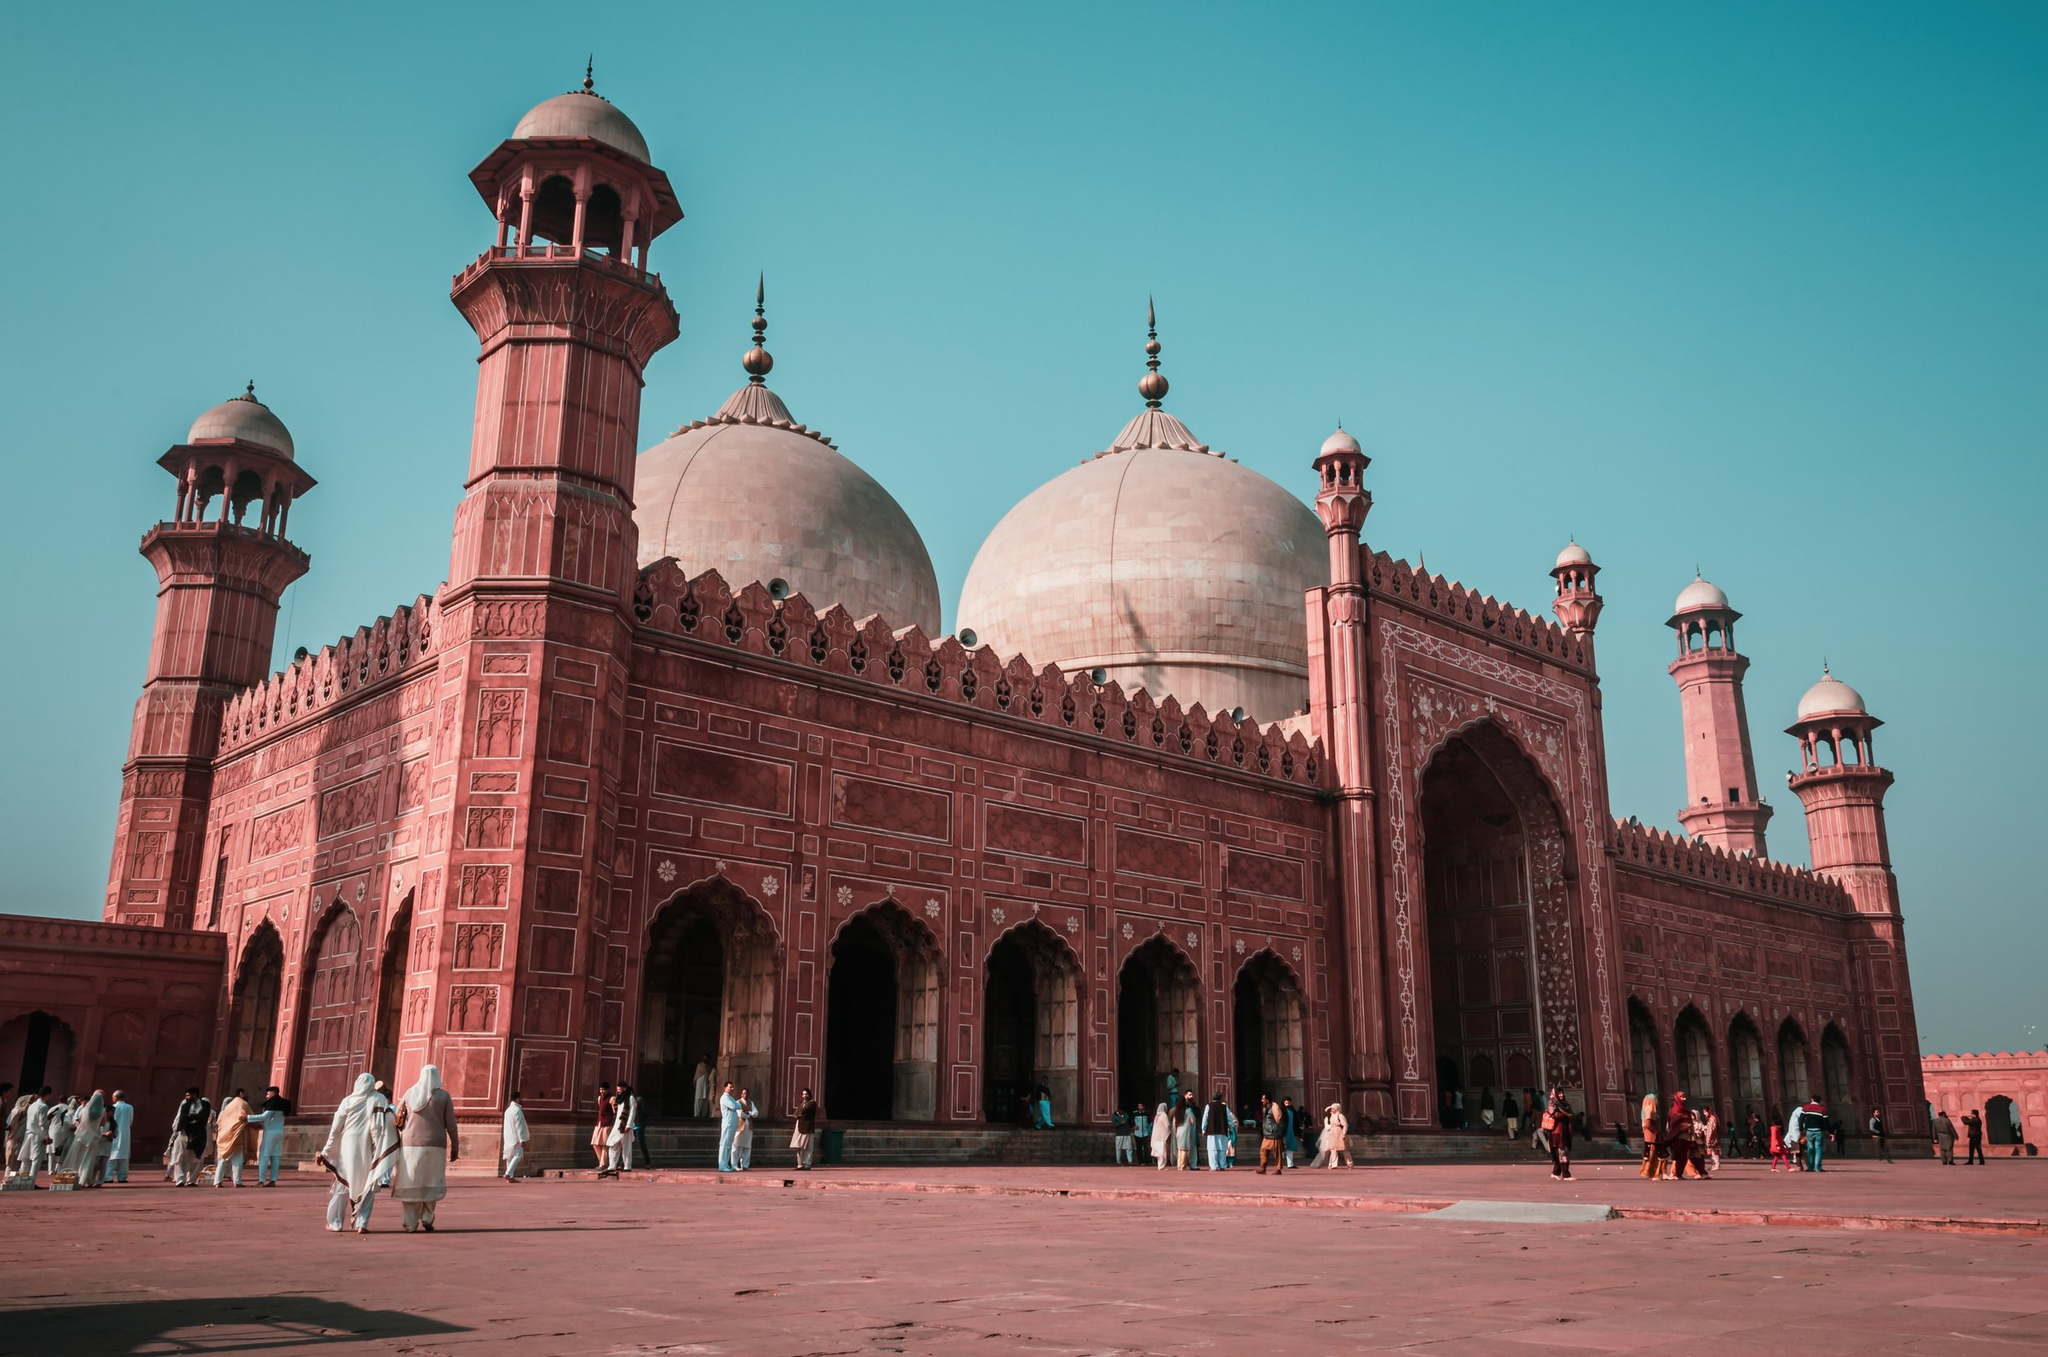Could you provide some historical context for this mosque? Absolutely. The Badshahi Mosque stands as a monument of the Mughal era, constructed under the reign of Emperor Aurangzeb in 1673. It was the largest mosque in the world at that time and served as a symbol of the empire's religious zeal and their commitment to creating monumental structures. The mosque has witnessed various historical events and has been used for different purposes over the centuries. During the Sikh Empire, it even served as a military garrison. It was later restored to its original purpose as a mosque and remains a potent symbol of the Islamic cultural identity in the region. 